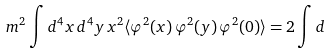Convert formula to latex. <formula><loc_0><loc_0><loc_500><loc_500>m ^ { 2 } \int d ^ { 4 } x \, d ^ { 4 } y \, x ^ { 2 } \langle \varphi ^ { 2 } ( x ) \, \varphi ^ { 2 } ( y ) \, \varphi ^ { 2 } ( 0 ) \rangle = 2 \int d</formula> 